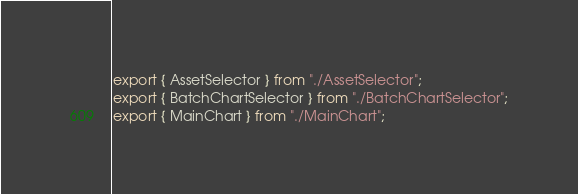Convert code to text. <code><loc_0><loc_0><loc_500><loc_500><_TypeScript_>export { AssetSelector } from "./AssetSelector";
export { BatchChartSelector } from "./BatchChartSelector";
export { MainChart } from "./MainChart";
</code> 